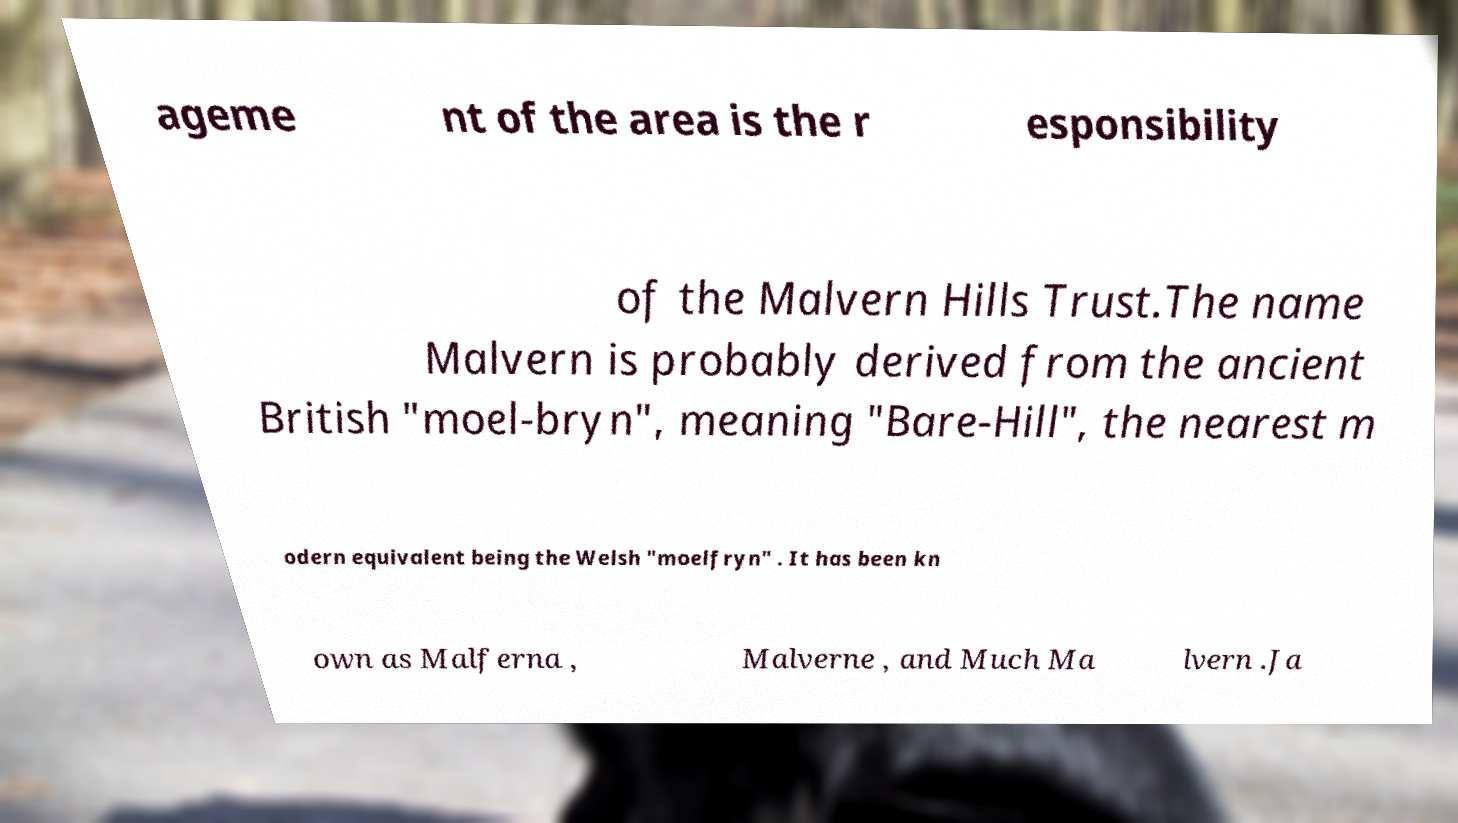There's text embedded in this image that I need extracted. Can you transcribe it verbatim? ageme nt of the area is the r esponsibility of the Malvern Hills Trust.The name Malvern is probably derived from the ancient British "moel-bryn", meaning "Bare-Hill", the nearest m odern equivalent being the Welsh "moelfryn" . It has been kn own as Malferna , Malverne , and Much Ma lvern .Ja 